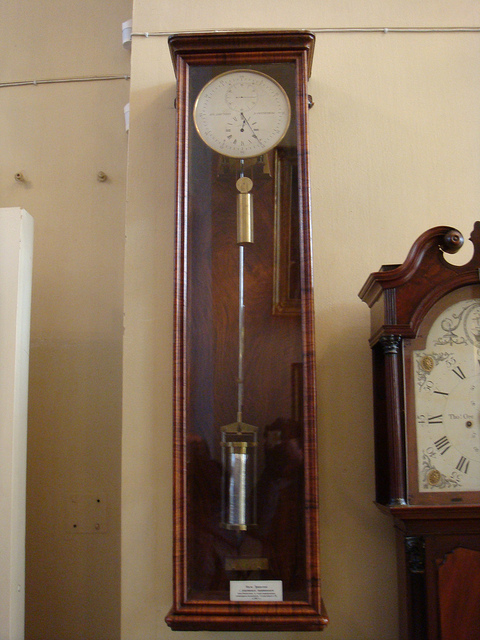Please transcribe the text in this image. VIII VII 